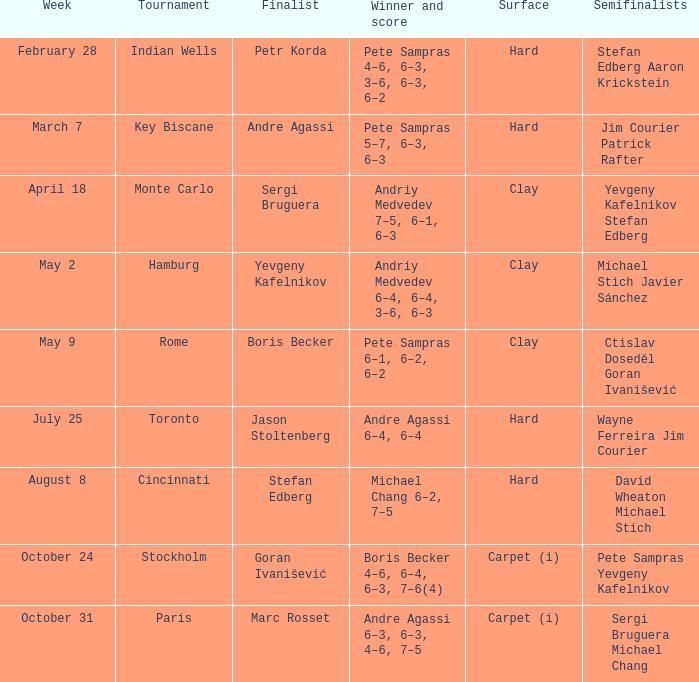Could you parse the entire table as a dict? {'header': ['Week', 'Tournament', 'Finalist', 'Winner and score', 'Surface', 'Semifinalists'], 'rows': [['February 28', 'Indian Wells', 'Petr Korda', 'Pete Sampras 4–6, 6–3, 3–6, 6–3, 6–2', 'Hard', 'Stefan Edberg Aaron Krickstein'], ['March 7', 'Key Biscane', 'Andre Agassi', 'Pete Sampras 5–7, 6–3, 6–3', 'Hard', 'Jim Courier Patrick Rafter'], ['April 18', 'Monte Carlo', 'Sergi Bruguera', 'Andriy Medvedev 7–5, 6–1, 6–3', 'Clay', 'Yevgeny Kafelnikov Stefan Edberg'], ['May 2', 'Hamburg', 'Yevgeny Kafelnikov', 'Andriy Medvedev 6–4, 6–4, 3–6, 6–3', 'Clay', 'Michael Stich Javier Sánchez'], ['May 9', 'Rome', 'Boris Becker', 'Pete Sampras 6–1, 6–2, 6–2', 'Clay', 'Ctislav Doseděl Goran Ivanišević'], ['July 25', 'Toronto', 'Jason Stoltenberg', 'Andre Agassi 6–4, 6–4', 'Hard', 'Wayne Ferreira Jim Courier'], ['August 8', 'Cincinnati', 'Stefan Edberg', 'Michael Chang 6–2, 7–5', 'Hard', 'David Wheaton Michael Stich'], ['October 24', 'Stockholm', 'Goran Ivanišević', 'Boris Becker 4–6, 6–4, 6–3, 7–6(4)', 'Carpet (i)', 'Pete Sampras Yevgeny Kafelnikov'], ['October 31', 'Paris', 'Marc Rosset', 'Andre Agassi 6–3, 6–3, 4–6, 7–5', 'Carpet (i)', 'Sergi Bruguera Michael Chang']]} Who was the semifinalist for the key biscane tournament? Jim Courier Patrick Rafter. 